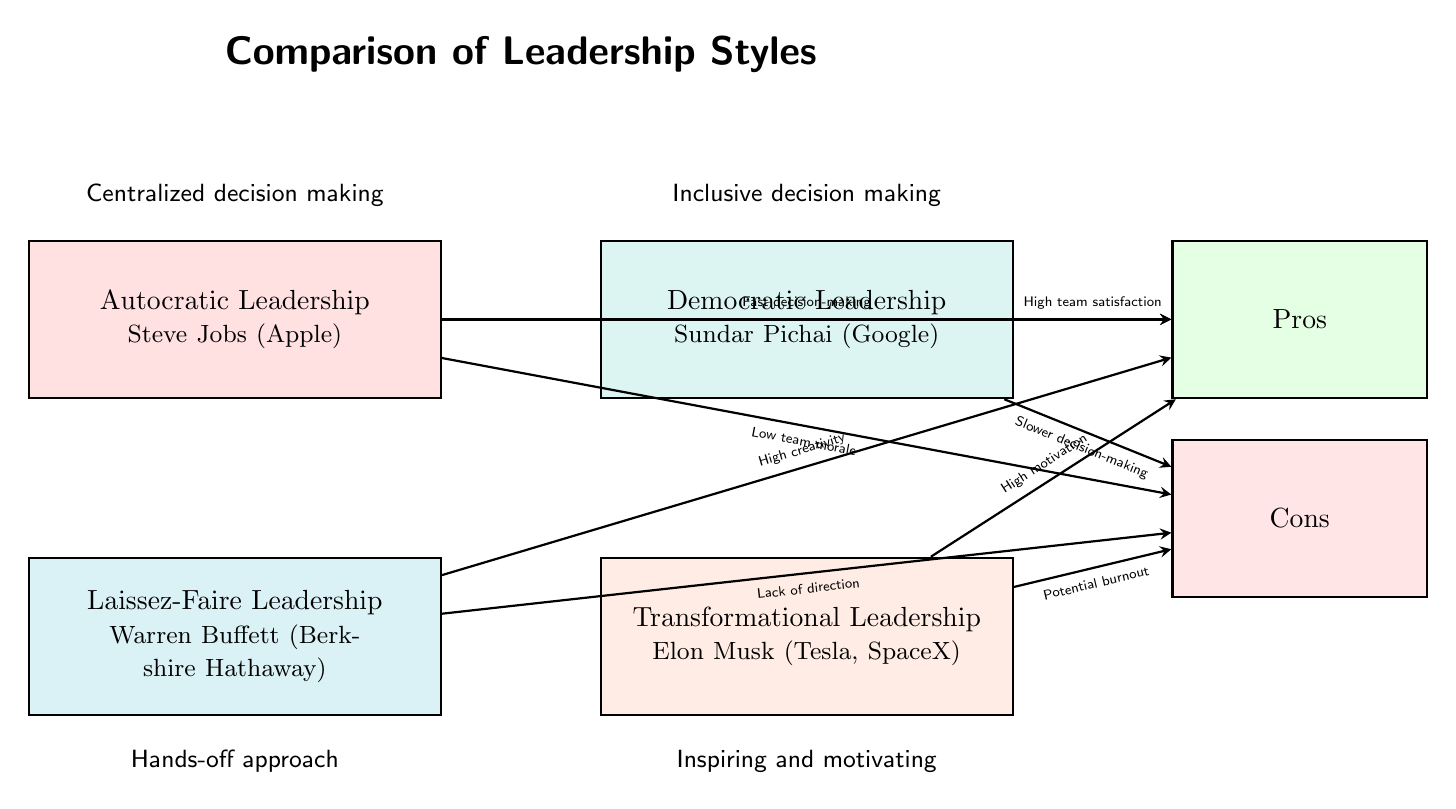What type of leadership is associated with Steve Jobs? The diagram shows that Steve Jobs is associated with Autocratic Leadership, indicated by the label beneath his name within the respective box.
Answer: Autocratic Leadership What is the main benefit of Democratic Leadership? The diagram states that the main benefit of Democratic Leadership, as indicated by the arrow pointing towards the "Pros" box, is High team satisfaction.
Answer: High team satisfaction How many cons are listed for Laissez-Faire Leadership? Upon examining the diagram, there is one arrow pointing from Laissez-Faire Leadership to the "Cons" box, indicating there is one listed con, which is Lack of direction.
Answer: 1 Which leadership style is linked to inspiring and motivating? The diagram clearly labels Transformational Leadership with the text "Inspiring and motivating" below it, directly indicating that this is the style linked to that quality.
Answer: Transformational Leadership What is the con associated with Transformational Leadership? The diagram illustrates that the con related to Transformational Leadership is Potential burnout, which is shown in the arrow pointing towards the "Cons" box.
Answer: Potential burnout Which leadership style is described as having a hands-off approach? The label beneath the Laissez-Faire Leadership box explicitly describes it as having a Hands-off approach, directly answering the question.
Answer: Hands-off approach What can we infer about decision-making speed in Autocratic Leadership? The diagram indicates that Autocratic Leadership has Fast decision-making as a pro, implying that decisions can be made quickly under this leadership style.
Answer: Fast decision-making Is there a reference to creativity in the diagram? Yes, the diagram attributes High creativity as a pro to Laissez-Faire Leadership, indicating a positive correlation between this style and creativity.
Answer: High creativity How does the diagram visually separate the leadership styles? The diagram uses different colored boxes to visually separate each leadership style, which aids in distinguishing their characteristics and related outcomes.
Answer: Different colored boxes 